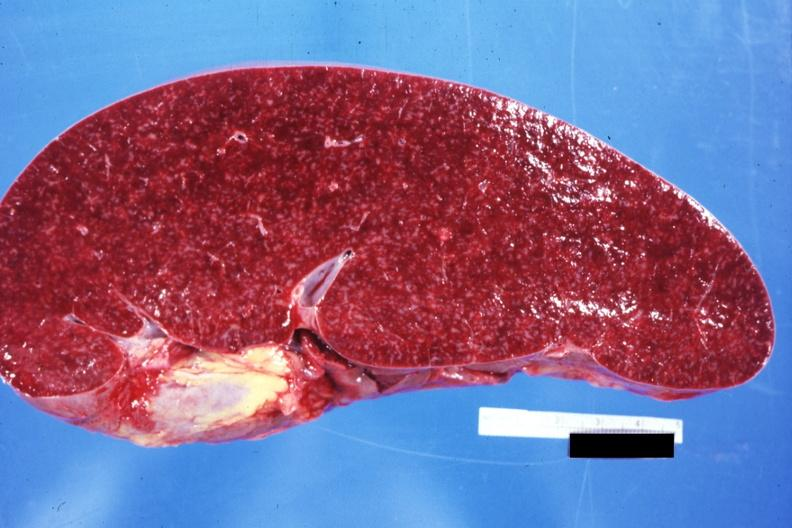s endocrine present?
Answer the question using a single word or phrase. No 